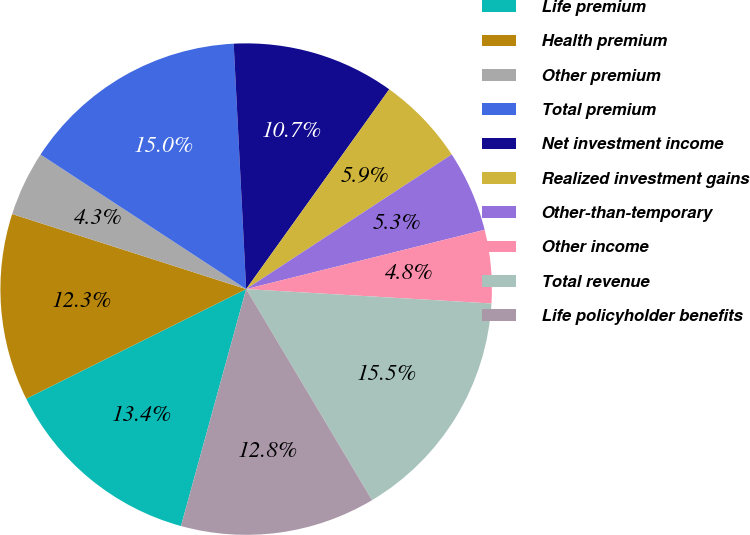Convert chart to OTSL. <chart><loc_0><loc_0><loc_500><loc_500><pie_chart><fcel>Life premium<fcel>Health premium<fcel>Other premium<fcel>Total premium<fcel>Net investment income<fcel>Realized investment gains<fcel>Other-than-temporary<fcel>Other income<fcel>Total revenue<fcel>Life policyholder benefits<nl><fcel>13.37%<fcel>12.3%<fcel>4.28%<fcel>14.97%<fcel>10.7%<fcel>5.88%<fcel>5.35%<fcel>4.81%<fcel>15.51%<fcel>12.83%<nl></chart> 